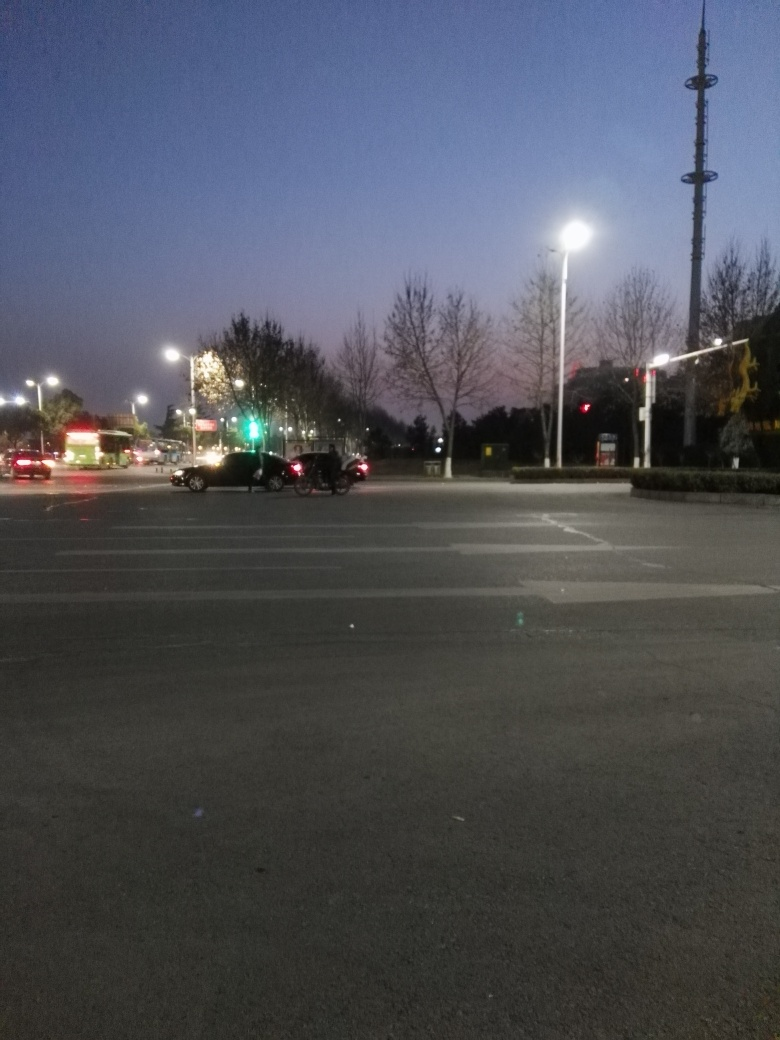Can you describe the atmosphere or mood conveyed by the image? The image evokes a tranquil evening setting, characterized by the soft glow of streetlights and a calm traffic flow. There's a serene quality to it, with a sky transitioning from sunset to dusk, giving off a peaceful yet slightly somber mood. What do the lighting and colors tell us about the time of day? The cool color palette, with varying shades of blue and sparse warm glows from the street lamps and vehicle lights, suggest that the photo was taken during twilight, just after the sun has set but before full nightfall. 